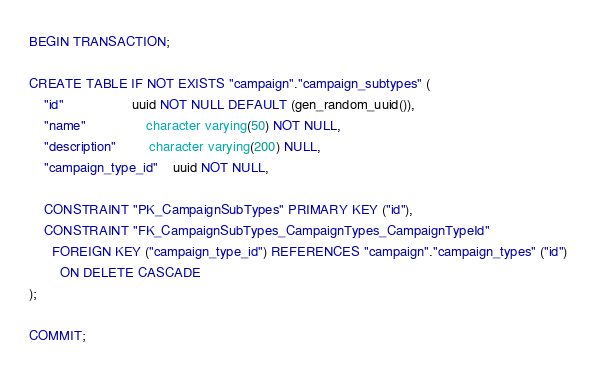Convert code to text. <code><loc_0><loc_0><loc_500><loc_500><_SQL_>BEGIN TRANSACTION;

CREATE TABLE IF NOT EXISTS "campaign"."campaign_subtypes" (
    "id"                  uuid NOT NULL DEFAULT (gen_random_uuid()),
    "name"                character varying(50) NOT NULL,
    "description"         character varying(200) NULL,
    "campaign_type_id"    uuid NOT NULL,

    CONSTRAINT "PK_CampaignSubTypes" PRIMARY KEY ("id"),
    CONSTRAINT "FK_CampaignSubTypes_CampaignTypes_CampaignTypeId"
      FOREIGN KEY ("campaign_type_id") REFERENCES "campaign"."campaign_types" ("id")
        ON DELETE CASCADE
);

COMMIT;
</code> 